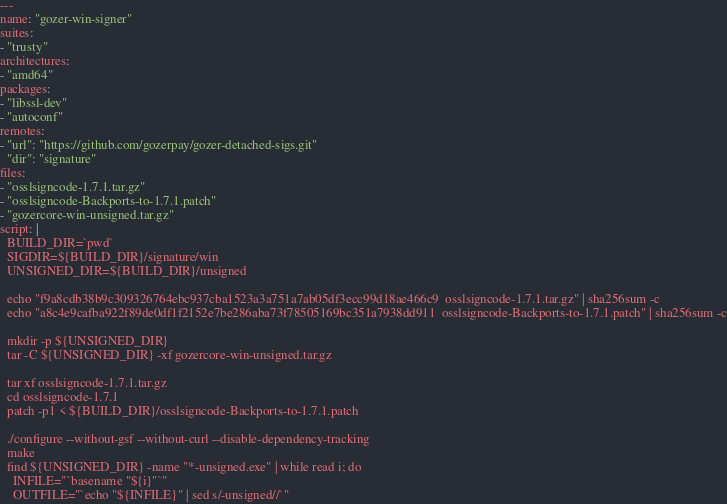<code> <loc_0><loc_0><loc_500><loc_500><_YAML_>---
name: "gozer-win-signer"
suites:
- "trusty"
architectures:
- "amd64"
packages:
- "libssl-dev"
- "autoconf"
remotes:
- "url": "https://github.com/gozerpay/gozer-detached-sigs.git"
  "dir": "signature"
files:
- "osslsigncode-1.7.1.tar.gz"
- "osslsigncode-Backports-to-1.7.1.patch"
- "gozercore-win-unsigned.tar.gz"
script: |
  BUILD_DIR=`pwd`
  SIGDIR=${BUILD_DIR}/signature/win
  UNSIGNED_DIR=${BUILD_DIR}/unsigned

  echo "f9a8cdb38b9c309326764ebc937cba1523a3a751a7ab05df3ecc99d18ae466c9  osslsigncode-1.7.1.tar.gz" | sha256sum -c
  echo "a8c4e9cafba922f89de0df1f2152e7be286aba73f78505169bc351a7938dd911  osslsigncode-Backports-to-1.7.1.patch" | sha256sum -c

  mkdir -p ${UNSIGNED_DIR}
  tar -C ${UNSIGNED_DIR} -xf gozercore-win-unsigned.tar.gz

  tar xf osslsigncode-1.7.1.tar.gz
  cd osslsigncode-1.7.1
  patch -p1 < ${BUILD_DIR}/osslsigncode-Backports-to-1.7.1.patch

  ./configure --without-gsf --without-curl --disable-dependency-tracking
  make
  find ${UNSIGNED_DIR} -name "*-unsigned.exe" | while read i; do
    INFILE="`basename "${i}"`"
    OUTFILE="`echo "${INFILE}" | sed s/-unsigned//`"</code> 